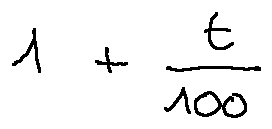Convert formula to latex. <formula><loc_0><loc_0><loc_500><loc_500>1 + \frac { t } { 1 0 0 }</formula> 